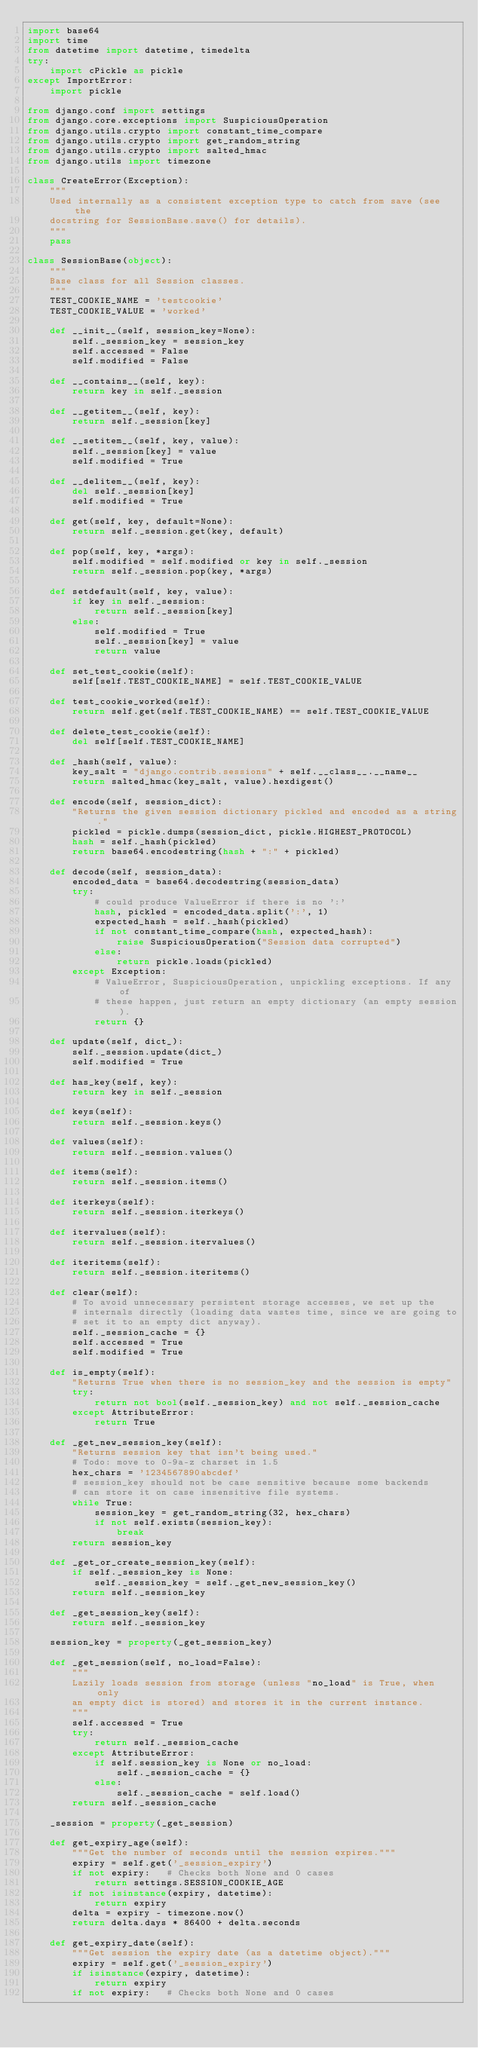<code> <loc_0><loc_0><loc_500><loc_500><_Python_>import base64
import time
from datetime import datetime, timedelta
try:
    import cPickle as pickle
except ImportError:
    import pickle

from django.conf import settings
from django.core.exceptions import SuspiciousOperation
from django.utils.crypto import constant_time_compare
from django.utils.crypto import get_random_string
from django.utils.crypto import salted_hmac
from django.utils import timezone

class CreateError(Exception):
    """
    Used internally as a consistent exception type to catch from save (see the
    docstring for SessionBase.save() for details).
    """
    pass

class SessionBase(object):
    """
    Base class for all Session classes.
    """
    TEST_COOKIE_NAME = 'testcookie'
    TEST_COOKIE_VALUE = 'worked'

    def __init__(self, session_key=None):
        self._session_key = session_key
        self.accessed = False
        self.modified = False

    def __contains__(self, key):
        return key in self._session

    def __getitem__(self, key):
        return self._session[key]

    def __setitem__(self, key, value):
        self._session[key] = value
        self.modified = True

    def __delitem__(self, key):
        del self._session[key]
        self.modified = True

    def get(self, key, default=None):
        return self._session.get(key, default)

    def pop(self, key, *args):
        self.modified = self.modified or key in self._session
        return self._session.pop(key, *args)

    def setdefault(self, key, value):
        if key in self._session:
            return self._session[key]
        else:
            self.modified = True
            self._session[key] = value
            return value

    def set_test_cookie(self):
        self[self.TEST_COOKIE_NAME] = self.TEST_COOKIE_VALUE

    def test_cookie_worked(self):
        return self.get(self.TEST_COOKIE_NAME) == self.TEST_COOKIE_VALUE

    def delete_test_cookie(self):
        del self[self.TEST_COOKIE_NAME]

    def _hash(self, value):
        key_salt = "django.contrib.sessions" + self.__class__.__name__
        return salted_hmac(key_salt, value).hexdigest()

    def encode(self, session_dict):
        "Returns the given session dictionary pickled and encoded as a string."
        pickled = pickle.dumps(session_dict, pickle.HIGHEST_PROTOCOL)
        hash = self._hash(pickled)
        return base64.encodestring(hash + ":" + pickled)

    def decode(self, session_data):
        encoded_data = base64.decodestring(session_data)
        try:
            # could produce ValueError if there is no ':'
            hash, pickled = encoded_data.split(':', 1)
            expected_hash = self._hash(pickled)
            if not constant_time_compare(hash, expected_hash):
                raise SuspiciousOperation("Session data corrupted")
            else:
                return pickle.loads(pickled)
        except Exception:
            # ValueError, SuspiciousOperation, unpickling exceptions. If any of
            # these happen, just return an empty dictionary (an empty session).
            return {}

    def update(self, dict_):
        self._session.update(dict_)
        self.modified = True

    def has_key(self, key):
        return key in self._session

    def keys(self):
        return self._session.keys()

    def values(self):
        return self._session.values()

    def items(self):
        return self._session.items()

    def iterkeys(self):
        return self._session.iterkeys()

    def itervalues(self):
        return self._session.itervalues()

    def iteritems(self):
        return self._session.iteritems()

    def clear(self):
        # To avoid unnecessary persistent storage accesses, we set up the
        # internals directly (loading data wastes time, since we are going to
        # set it to an empty dict anyway).
        self._session_cache = {}
        self.accessed = True
        self.modified = True

    def is_empty(self):
        "Returns True when there is no session_key and the session is empty"
        try:
            return not bool(self._session_key) and not self._session_cache
        except AttributeError:
            return True

    def _get_new_session_key(self):
        "Returns session key that isn't being used."
        # Todo: move to 0-9a-z charset in 1.5
        hex_chars = '1234567890abcdef'
        # session_key should not be case sensitive because some backends
        # can store it on case insensitive file systems.
        while True:
            session_key = get_random_string(32, hex_chars)
            if not self.exists(session_key):
                break
        return session_key

    def _get_or_create_session_key(self):
        if self._session_key is None:
            self._session_key = self._get_new_session_key()
        return self._session_key

    def _get_session_key(self):
        return self._session_key

    session_key = property(_get_session_key)

    def _get_session(self, no_load=False):
        """
        Lazily loads session from storage (unless "no_load" is True, when only
        an empty dict is stored) and stores it in the current instance.
        """
        self.accessed = True
        try:
            return self._session_cache
        except AttributeError:
            if self.session_key is None or no_load:
                self._session_cache = {}
            else:
                self._session_cache = self.load()
        return self._session_cache

    _session = property(_get_session)

    def get_expiry_age(self):
        """Get the number of seconds until the session expires."""
        expiry = self.get('_session_expiry')
        if not expiry:   # Checks both None and 0 cases
            return settings.SESSION_COOKIE_AGE
        if not isinstance(expiry, datetime):
            return expiry
        delta = expiry - timezone.now()
        return delta.days * 86400 + delta.seconds

    def get_expiry_date(self):
        """Get session the expiry date (as a datetime object)."""
        expiry = self.get('_session_expiry')
        if isinstance(expiry, datetime):
            return expiry
        if not expiry:   # Checks both None and 0 cases</code> 